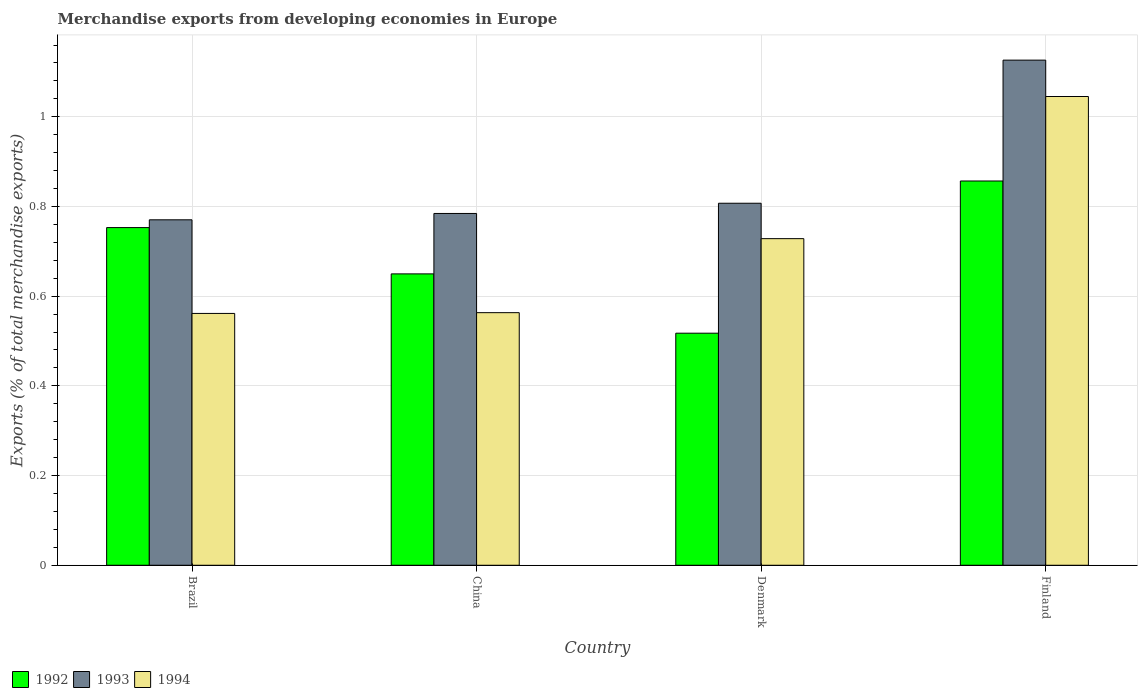How many different coloured bars are there?
Your answer should be compact. 3. Are the number of bars on each tick of the X-axis equal?
Ensure brevity in your answer.  Yes. How many bars are there on the 2nd tick from the left?
Your answer should be very brief. 3. What is the label of the 4th group of bars from the left?
Your answer should be compact. Finland. What is the percentage of total merchandise exports in 1993 in Denmark?
Provide a short and direct response. 0.81. Across all countries, what is the maximum percentage of total merchandise exports in 1993?
Your answer should be very brief. 1.13. Across all countries, what is the minimum percentage of total merchandise exports in 1992?
Provide a succinct answer. 0.52. What is the total percentage of total merchandise exports in 1993 in the graph?
Provide a short and direct response. 3.49. What is the difference between the percentage of total merchandise exports in 1993 in Brazil and that in China?
Provide a succinct answer. -0.01. What is the difference between the percentage of total merchandise exports in 1992 in Denmark and the percentage of total merchandise exports in 1994 in Brazil?
Your response must be concise. -0.04. What is the average percentage of total merchandise exports in 1992 per country?
Make the answer very short. 0.69. What is the difference between the percentage of total merchandise exports of/in 1992 and percentage of total merchandise exports of/in 1993 in Denmark?
Offer a very short reply. -0.29. In how many countries, is the percentage of total merchandise exports in 1994 greater than 0.68 %?
Your answer should be very brief. 2. What is the ratio of the percentage of total merchandise exports in 1993 in Denmark to that in Finland?
Offer a very short reply. 0.72. Is the percentage of total merchandise exports in 1992 in China less than that in Denmark?
Offer a terse response. No. Is the difference between the percentage of total merchandise exports in 1992 in China and Denmark greater than the difference between the percentage of total merchandise exports in 1993 in China and Denmark?
Provide a short and direct response. Yes. What is the difference between the highest and the second highest percentage of total merchandise exports in 1993?
Your response must be concise. -0.32. What is the difference between the highest and the lowest percentage of total merchandise exports in 1992?
Provide a short and direct response. 0.34. In how many countries, is the percentage of total merchandise exports in 1993 greater than the average percentage of total merchandise exports in 1993 taken over all countries?
Give a very brief answer. 1. Is the sum of the percentage of total merchandise exports in 1993 in Brazil and China greater than the maximum percentage of total merchandise exports in 1994 across all countries?
Offer a terse response. Yes. What does the 3rd bar from the right in Brazil represents?
Your response must be concise. 1992. How many bars are there?
Ensure brevity in your answer.  12. How many countries are there in the graph?
Give a very brief answer. 4. What is the difference between two consecutive major ticks on the Y-axis?
Your answer should be compact. 0.2. Are the values on the major ticks of Y-axis written in scientific E-notation?
Provide a short and direct response. No. Does the graph contain any zero values?
Offer a very short reply. No. Where does the legend appear in the graph?
Your answer should be very brief. Bottom left. How many legend labels are there?
Provide a short and direct response. 3. How are the legend labels stacked?
Provide a succinct answer. Horizontal. What is the title of the graph?
Keep it short and to the point. Merchandise exports from developing economies in Europe. Does "1994" appear as one of the legend labels in the graph?
Offer a very short reply. Yes. What is the label or title of the Y-axis?
Your response must be concise. Exports (% of total merchandise exports). What is the Exports (% of total merchandise exports) in 1992 in Brazil?
Offer a terse response. 0.75. What is the Exports (% of total merchandise exports) in 1993 in Brazil?
Ensure brevity in your answer.  0.77. What is the Exports (% of total merchandise exports) of 1994 in Brazil?
Provide a succinct answer. 0.56. What is the Exports (% of total merchandise exports) in 1992 in China?
Make the answer very short. 0.65. What is the Exports (% of total merchandise exports) of 1993 in China?
Offer a very short reply. 0.78. What is the Exports (% of total merchandise exports) of 1994 in China?
Your answer should be compact. 0.56. What is the Exports (% of total merchandise exports) of 1992 in Denmark?
Provide a short and direct response. 0.52. What is the Exports (% of total merchandise exports) of 1993 in Denmark?
Give a very brief answer. 0.81. What is the Exports (% of total merchandise exports) in 1994 in Denmark?
Your response must be concise. 0.73. What is the Exports (% of total merchandise exports) in 1992 in Finland?
Offer a very short reply. 0.86. What is the Exports (% of total merchandise exports) of 1993 in Finland?
Keep it short and to the point. 1.13. What is the Exports (% of total merchandise exports) of 1994 in Finland?
Your answer should be compact. 1.05. Across all countries, what is the maximum Exports (% of total merchandise exports) of 1992?
Your answer should be very brief. 0.86. Across all countries, what is the maximum Exports (% of total merchandise exports) of 1993?
Keep it short and to the point. 1.13. Across all countries, what is the maximum Exports (% of total merchandise exports) of 1994?
Your answer should be very brief. 1.05. Across all countries, what is the minimum Exports (% of total merchandise exports) of 1992?
Provide a succinct answer. 0.52. Across all countries, what is the minimum Exports (% of total merchandise exports) in 1993?
Provide a short and direct response. 0.77. Across all countries, what is the minimum Exports (% of total merchandise exports) in 1994?
Your answer should be compact. 0.56. What is the total Exports (% of total merchandise exports) of 1992 in the graph?
Offer a terse response. 2.78. What is the total Exports (% of total merchandise exports) in 1993 in the graph?
Give a very brief answer. 3.49. What is the total Exports (% of total merchandise exports) in 1994 in the graph?
Offer a terse response. 2.9. What is the difference between the Exports (% of total merchandise exports) of 1992 in Brazil and that in China?
Provide a short and direct response. 0.1. What is the difference between the Exports (% of total merchandise exports) in 1993 in Brazil and that in China?
Your answer should be very brief. -0.01. What is the difference between the Exports (% of total merchandise exports) of 1994 in Brazil and that in China?
Make the answer very short. -0. What is the difference between the Exports (% of total merchandise exports) in 1992 in Brazil and that in Denmark?
Your answer should be compact. 0.24. What is the difference between the Exports (% of total merchandise exports) in 1993 in Brazil and that in Denmark?
Offer a very short reply. -0.04. What is the difference between the Exports (% of total merchandise exports) of 1994 in Brazil and that in Denmark?
Your answer should be compact. -0.17. What is the difference between the Exports (% of total merchandise exports) of 1992 in Brazil and that in Finland?
Give a very brief answer. -0.1. What is the difference between the Exports (% of total merchandise exports) in 1993 in Brazil and that in Finland?
Provide a succinct answer. -0.36. What is the difference between the Exports (% of total merchandise exports) of 1994 in Brazil and that in Finland?
Give a very brief answer. -0.48. What is the difference between the Exports (% of total merchandise exports) in 1992 in China and that in Denmark?
Provide a succinct answer. 0.13. What is the difference between the Exports (% of total merchandise exports) of 1993 in China and that in Denmark?
Keep it short and to the point. -0.02. What is the difference between the Exports (% of total merchandise exports) in 1994 in China and that in Denmark?
Provide a succinct answer. -0.17. What is the difference between the Exports (% of total merchandise exports) of 1992 in China and that in Finland?
Provide a succinct answer. -0.21. What is the difference between the Exports (% of total merchandise exports) of 1993 in China and that in Finland?
Your answer should be compact. -0.34. What is the difference between the Exports (% of total merchandise exports) of 1994 in China and that in Finland?
Offer a terse response. -0.48. What is the difference between the Exports (% of total merchandise exports) of 1992 in Denmark and that in Finland?
Offer a terse response. -0.34. What is the difference between the Exports (% of total merchandise exports) in 1993 in Denmark and that in Finland?
Give a very brief answer. -0.32. What is the difference between the Exports (% of total merchandise exports) in 1994 in Denmark and that in Finland?
Offer a terse response. -0.32. What is the difference between the Exports (% of total merchandise exports) in 1992 in Brazil and the Exports (% of total merchandise exports) in 1993 in China?
Keep it short and to the point. -0.03. What is the difference between the Exports (% of total merchandise exports) of 1992 in Brazil and the Exports (% of total merchandise exports) of 1994 in China?
Provide a succinct answer. 0.19. What is the difference between the Exports (% of total merchandise exports) in 1993 in Brazil and the Exports (% of total merchandise exports) in 1994 in China?
Keep it short and to the point. 0.21. What is the difference between the Exports (% of total merchandise exports) of 1992 in Brazil and the Exports (% of total merchandise exports) of 1993 in Denmark?
Give a very brief answer. -0.05. What is the difference between the Exports (% of total merchandise exports) of 1992 in Brazil and the Exports (% of total merchandise exports) of 1994 in Denmark?
Offer a very short reply. 0.02. What is the difference between the Exports (% of total merchandise exports) in 1993 in Brazil and the Exports (% of total merchandise exports) in 1994 in Denmark?
Ensure brevity in your answer.  0.04. What is the difference between the Exports (% of total merchandise exports) in 1992 in Brazil and the Exports (% of total merchandise exports) in 1993 in Finland?
Give a very brief answer. -0.37. What is the difference between the Exports (% of total merchandise exports) of 1992 in Brazil and the Exports (% of total merchandise exports) of 1994 in Finland?
Your response must be concise. -0.29. What is the difference between the Exports (% of total merchandise exports) of 1993 in Brazil and the Exports (% of total merchandise exports) of 1994 in Finland?
Your answer should be very brief. -0.27. What is the difference between the Exports (% of total merchandise exports) of 1992 in China and the Exports (% of total merchandise exports) of 1993 in Denmark?
Make the answer very short. -0.16. What is the difference between the Exports (% of total merchandise exports) in 1992 in China and the Exports (% of total merchandise exports) in 1994 in Denmark?
Give a very brief answer. -0.08. What is the difference between the Exports (% of total merchandise exports) in 1993 in China and the Exports (% of total merchandise exports) in 1994 in Denmark?
Make the answer very short. 0.06. What is the difference between the Exports (% of total merchandise exports) in 1992 in China and the Exports (% of total merchandise exports) in 1993 in Finland?
Give a very brief answer. -0.48. What is the difference between the Exports (% of total merchandise exports) in 1992 in China and the Exports (% of total merchandise exports) in 1994 in Finland?
Keep it short and to the point. -0.4. What is the difference between the Exports (% of total merchandise exports) of 1993 in China and the Exports (% of total merchandise exports) of 1994 in Finland?
Your answer should be very brief. -0.26. What is the difference between the Exports (% of total merchandise exports) in 1992 in Denmark and the Exports (% of total merchandise exports) in 1993 in Finland?
Make the answer very short. -0.61. What is the difference between the Exports (% of total merchandise exports) of 1992 in Denmark and the Exports (% of total merchandise exports) of 1994 in Finland?
Keep it short and to the point. -0.53. What is the difference between the Exports (% of total merchandise exports) in 1993 in Denmark and the Exports (% of total merchandise exports) in 1994 in Finland?
Your answer should be very brief. -0.24. What is the average Exports (% of total merchandise exports) in 1992 per country?
Ensure brevity in your answer.  0.69. What is the average Exports (% of total merchandise exports) of 1993 per country?
Keep it short and to the point. 0.87. What is the average Exports (% of total merchandise exports) of 1994 per country?
Your answer should be very brief. 0.72. What is the difference between the Exports (% of total merchandise exports) of 1992 and Exports (% of total merchandise exports) of 1993 in Brazil?
Offer a very short reply. -0.02. What is the difference between the Exports (% of total merchandise exports) in 1992 and Exports (% of total merchandise exports) in 1994 in Brazil?
Offer a terse response. 0.19. What is the difference between the Exports (% of total merchandise exports) in 1993 and Exports (% of total merchandise exports) in 1994 in Brazil?
Ensure brevity in your answer.  0.21. What is the difference between the Exports (% of total merchandise exports) in 1992 and Exports (% of total merchandise exports) in 1993 in China?
Offer a terse response. -0.13. What is the difference between the Exports (% of total merchandise exports) of 1992 and Exports (% of total merchandise exports) of 1994 in China?
Offer a terse response. 0.09. What is the difference between the Exports (% of total merchandise exports) of 1993 and Exports (% of total merchandise exports) of 1994 in China?
Provide a short and direct response. 0.22. What is the difference between the Exports (% of total merchandise exports) of 1992 and Exports (% of total merchandise exports) of 1993 in Denmark?
Make the answer very short. -0.29. What is the difference between the Exports (% of total merchandise exports) in 1992 and Exports (% of total merchandise exports) in 1994 in Denmark?
Provide a succinct answer. -0.21. What is the difference between the Exports (% of total merchandise exports) in 1993 and Exports (% of total merchandise exports) in 1994 in Denmark?
Give a very brief answer. 0.08. What is the difference between the Exports (% of total merchandise exports) of 1992 and Exports (% of total merchandise exports) of 1993 in Finland?
Offer a terse response. -0.27. What is the difference between the Exports (% of total merchandise exports) in 1992 and Exports (% of total merchandise exports) in 1994 in Finland?
Your answer should be very brief. -0.19. What is the difference between the Exports (% of total merchandise exports) of 1993 and Exports (% of total merchandise exports) of 1994 in Finland?
Make the answer very short. 0.08. What is the ratio of the Exports (% of total merchandise exports) in 1992 in Brazil to that in China?
Keep it short and to the point. 1.16. What is the ratio of the Exports (% of total merchandise exports) in 1993 in Brazil to that in China?
Ensure brevity in your answer.  0.98. What is the ratio of the Exports (% of total merchandise exports) in 1992 in Brazil to that in Denmark?
Your answer should be compact. 1.46. What is the ratio of the Exports (% of total merchandise exports) in 1993 in Brazil to that in Denmark?
Offer a terse response. 0.95. What is the ratio of the Exports (% of total merchandise exports) of 1994 in Brazil to that in Denmark?
Give a very brief answer. 0.77. What is the ratio of the Exports (% of total merchandise exports) of 1992 in Brazil to that in Finland?
Provide a short and direct response. 0.88. What is the ratio of the Exports (% of total merchandise exports) of 1993 in Brazil to that in Finland?
Provide a succinct answer. 0.68. What is the ratio of the Exports (% of total merchandise exports) of 1994 in Brazil to that in Finland?
Offer a terse response. 0.54. What is the ratio of the Exports (% of total merchandise exports) in 1992 in China to that in Denmark?
Offer a very short reply. 1.26. What is the ratio of the Exports (% of total merchandise exports) of 1993 in China to that in Denmark?
Provide a succinct answer. 0.97. What is the ratio of the Exports (% of total merchandise exports) of 1994 in China to that in Denmark?
Your response must be concise. 0.77. What is the ratio of the Exports (% of total merchandise exports) of 1992 in China to that in Finland?
Your answer should be compact. 0.76. What is the ratio of the Exports (% of total merchandise exports) of 1993 in China to that in Finland?
Your answer should be very brief. 0.7. What is the ratio of the Exports (% of total merchandise exports) of 1994 in China to that in Finland?
Your answer should be compact. 0.54. What is the ratio of the Exports (% of total merchandise exports) in 1992 in Denmark to that in Finland?
Offer a terse response. 0.6. What is the ratio of the Exports (% of total merchandise exports) in 1993 in Denmark to that in Finland?
Make the answer very short. 0.72. What is the ratio of the Exports (% of total merchandise exports) of 1994 in Denmark to that in Finland?
Provide a short and direct response. 0.7. What is the difference between the highest and the second highest Exports (% of total merchandise exports) in 1992?
Give a very brief answer. 0.1. What is the difference between the highest and the second highest Exports (% of total merchandise exports) of 1993?
Provide a succinct answer. 0.32. What is the difference between the highest and the second highest Exports (% of total merchandise exports) of 1994?
Make the answer very short. 0.32. What is the difference between the highest and the lowest Exports (% of total merchandise exports) in 1992?
Your answer should be very brief. 0.34. What is the difference between the highest and the lowest Exports (% of total merchandise exports) in 1993?
Keep it short and to the point. 0.36. What is the difference between the highest and the lowest Exports (% of total merchandise exports) of 1994?
Make the answer very short. 0.48. 